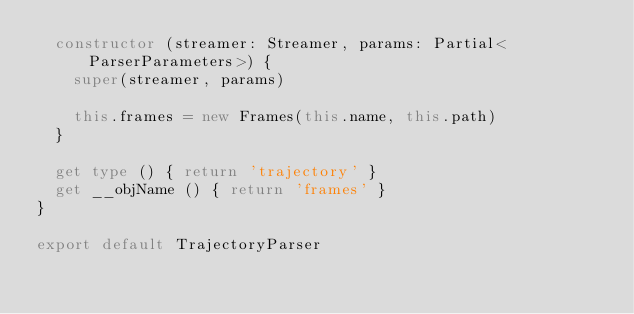Convert code to text. <code><loc_0><loc_0><loc_500><loc_500><_TypeScript_>  constructor (streamer: Streamer, params: Partial<ParserParameters>) {
    super(streamer, params)

    this.frames = new Frames(this.name, this.path)
  }

  get type () { return 'trajectory' }
  get __objName () { return 'frames' }
}

export default TrajectoryParser
</code> 